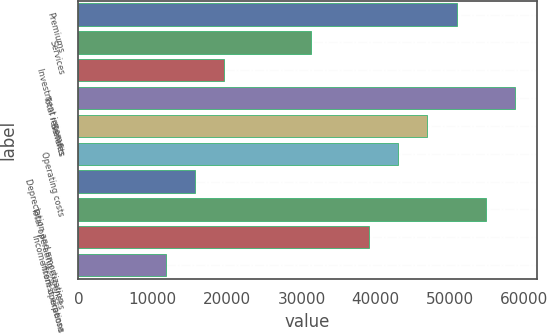Convert chart to OTSL. <chart><loc_0><loc_0><loc_500><loc_500><bar_chart><fcel>Premiums<fcel>Services<fcel>Investment income<fcel>Total revenues<fcel>Benefits<fcel>Operating costs<fcel>Depreciation and amortization<fcel>Total operating expenses<fcel>Income from operations<fcel>Interest expense<nl><fcel>50863.5<fcel>31301<fcel>19563.5<fcel>58688.5<fcel>46951<fcel>43038.5<fcel>15651<fcel>54776<fcel>39126<fcel>11738.5<nl></chart> 